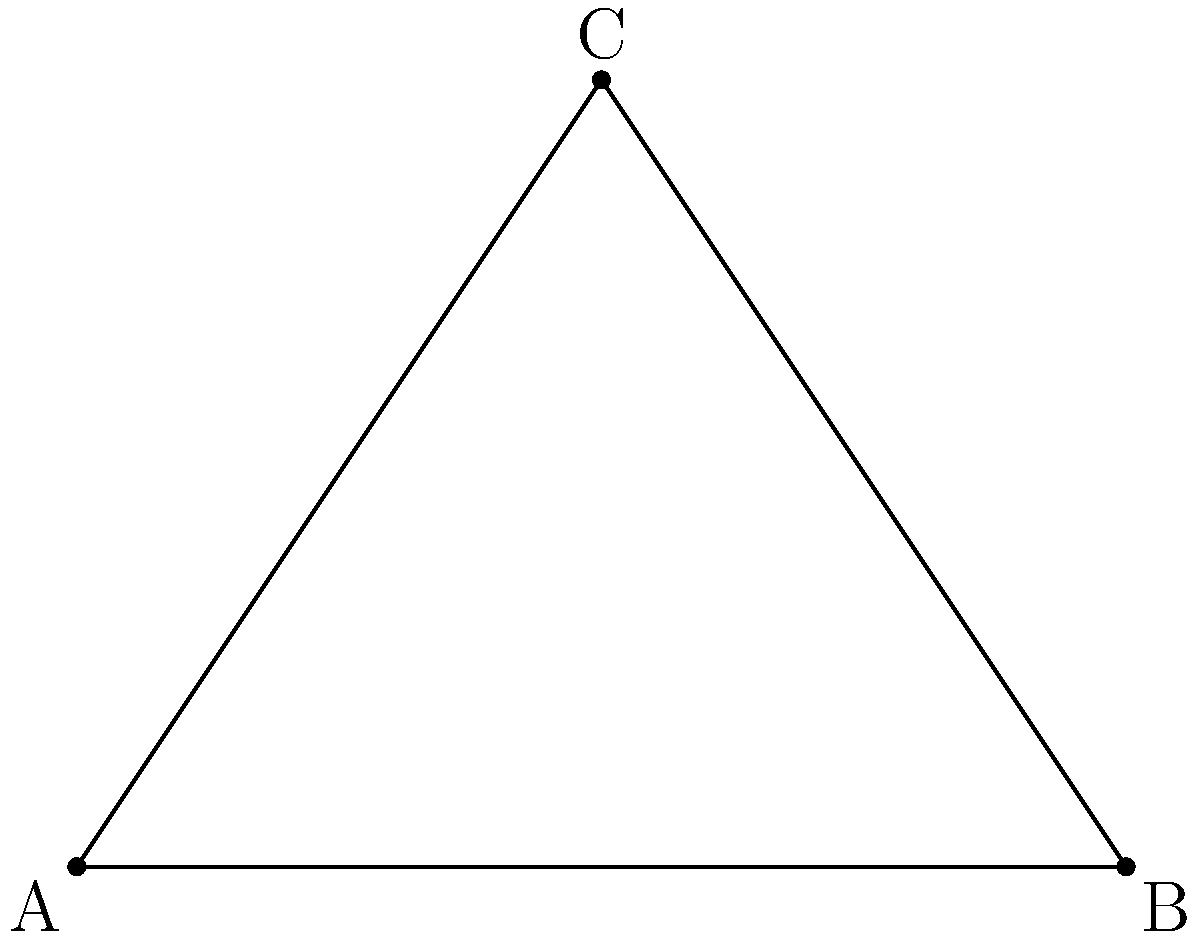A security camera needs to be installed at point C to monitor the entrance of a building (point A) and the corner of a fence (point B). The distance between A and B is 20 meters, and the camera will be mounted 15 meters away from the midpoint of AB. What is the optimal angle $\theta$ for the camera's field of view to capture both points A and B? To solve this problem, we'll follow these steps:

1) First, we need to recognize that this forms a right-angled triangle, with the right angle at C.

2) We can split this triangle into two equal right-angled triangles by drawing a line from C to the midpoint of AB.

3) In one of these smaller triangles:
   - The base (half of AB) is 10 meters (20/2)
   - The height (perpendicular from C to AB) is 15 meters

4) We can use the trigonometric function tangent to find half of the angle $\theta$:

   $$\tan(\frac{\theta}{2}) = \frac{\text{opposite}}{\text{adjacent}} = \frac{10}{15} = \frac{2}{3}$$

5) To find $\frac{\theta}{2}$, we take the inverse tangent (arctan or $\tan^{-1}$):

   $$\frac{\theta}{2} = \tan^{-1}(\frac{2}{3})$$

6) To get the full angle $\theta$, we multiply this by 2:

   $$\theta = 2 \times \tan^{-1}(\frac{2}{3})$$

7) Calculating this:
   $$\theta \approx 2 \times 33.69° = 67.38°$$

Therefore, the optimal angle for the camera's field of view is approximately 67.38°.
Answer: $67.38°$ 